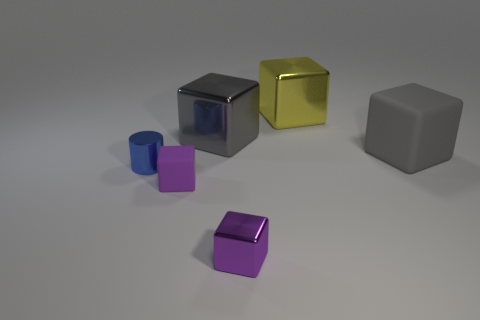There is a gray cube that is on the right side of the big yellow thing; what size is it?
Offer a very short reply. Large. Are there any purple metal objects that have the same size as the gray matte thing?
Offer a terse response. No. There is a cylinder that is in front of the yellow cube; does it have the same size as the gray matte object?
Offer a very short reply. No. What size is the purple rubber thing?
Ensure brevity in your answer.  Small. There is a large metallic thing on the right side of the big gray thing that is left of the gray object right of the large gray shiny thing; what color is it?
Give a very brief answer. Yellow. Does the metal block left of the small purple metal cube have the same color as the small rubber thing?
Your answer should be compact. No. How many objects are both behind the tiny blue metallic cylinder and in front of the shiny cylinder?
Keep it short and to the point. 0. There is a purple rubber thing that is the same shape as the yellow thing; what size is it?
Your response must be concise. Small. How many small purple metallic blocks are left of the small shiny object to the left of the metal thing in front of the blue metallic object?
Ensure brevity in your answer.  0. What color is the matte object that is to the left of the gray thing that is right of the small metallic cube?
Your answer should be very brief. Purple. 